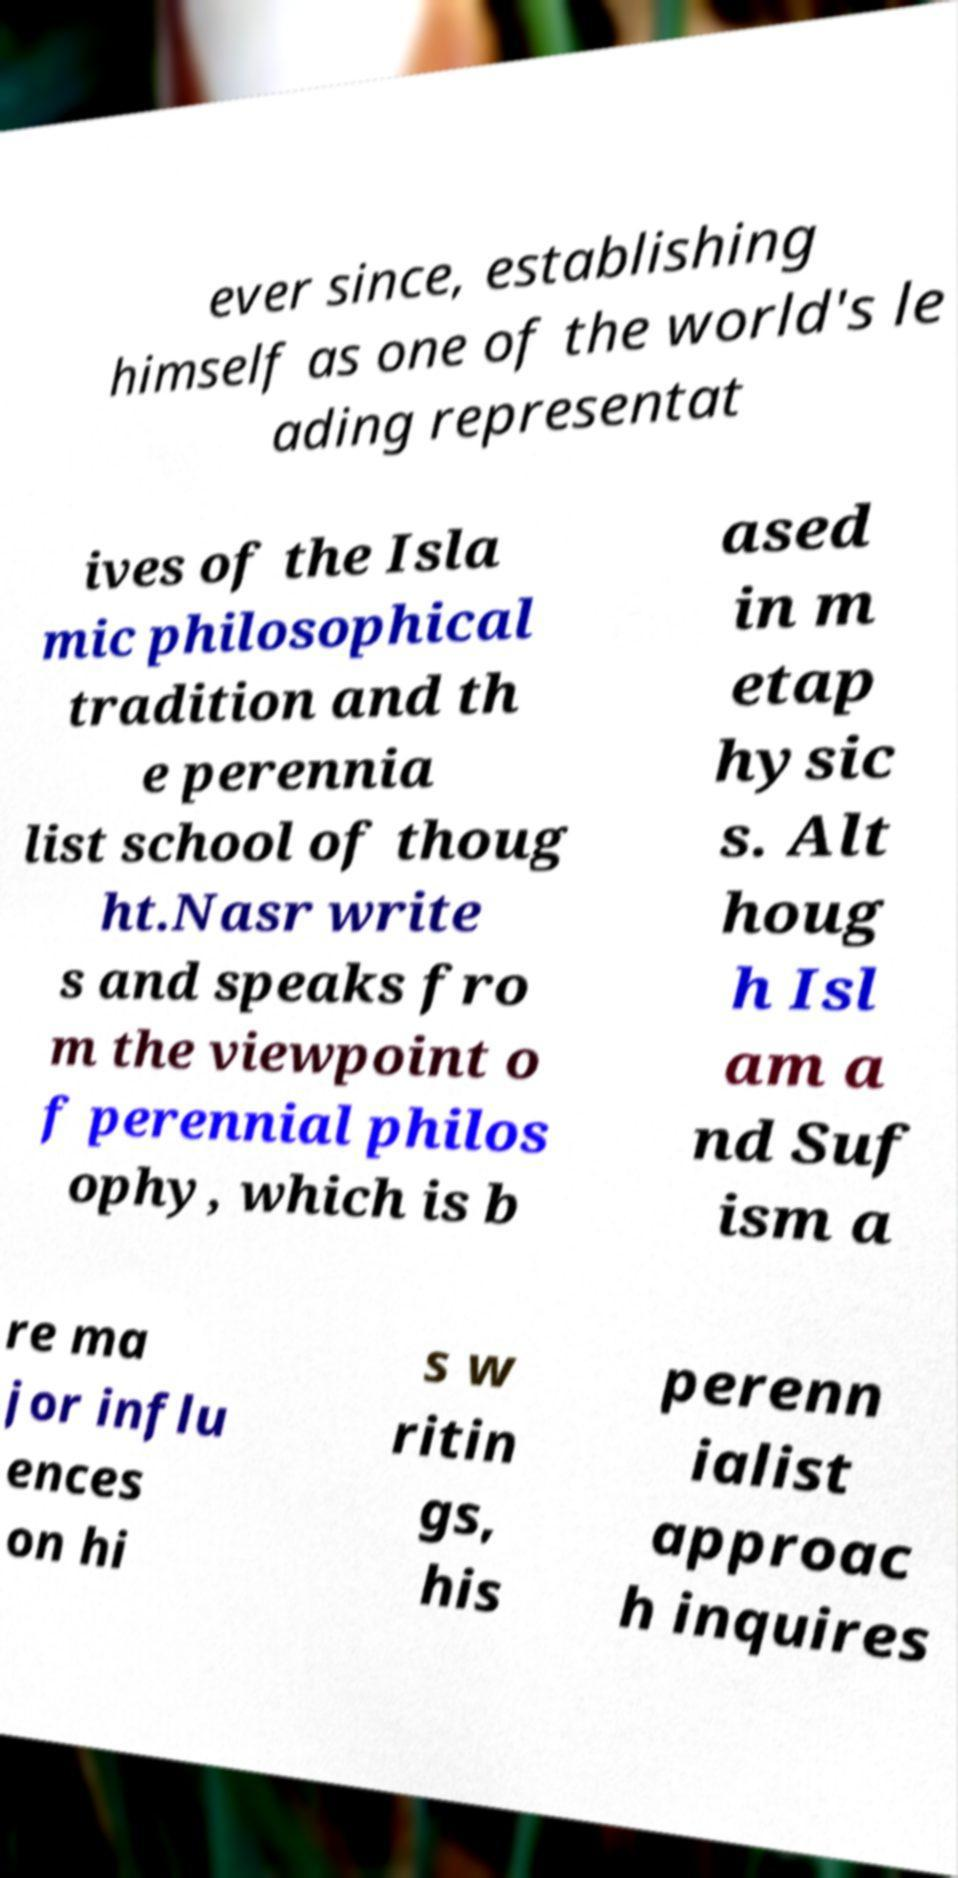Please read and relay the text visible in this image. What does it say? ever since, establishing himself as one of the world's le ading representat ives of the Isla mic philosophical tradition and th e perennia list school of thoug ht.Nasr write s and speaks fro m the viewpoint o f perennial philos ophy, which is b ased in m etap hysic s. Alt houg h Isl am a nd Suf ism a re ma jor influ ences on hi s w ritin gs, his perenn ialist approac h inquires 